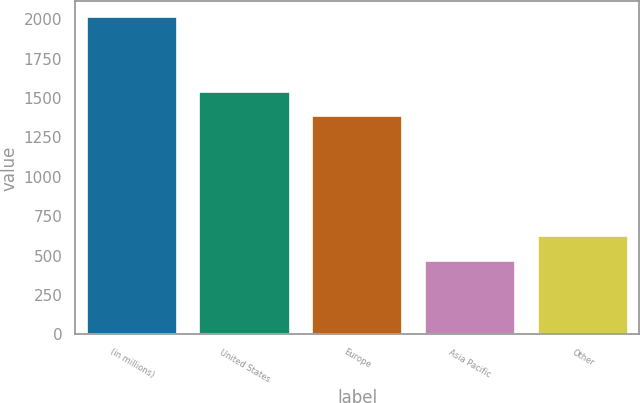Convert chart. <chart><loc_0><loc_0><loc_500><loc_500><bar_chart><fcel>(in millions)<fcel>United States<fcel>Europe<fcel>Asia Pacific<fcel>Other<nl><fcel>2013<fcel>1541.6<fcel>1387<fcel>467<fcel>621.6<nl></chart> 